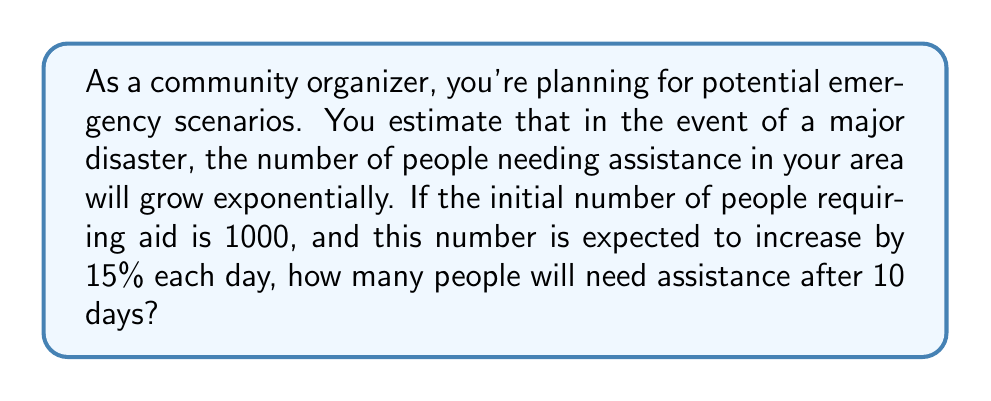Provide a solution to this math problem. Let's approach this step-by-step using an exponential function:

1) The general form of an exponential growth function is:
   $$ P(t) = P_0 \cdot (1 + r)^t $$
   Where:
   $P(t)$ is the population at time $t$
   $P_0$ is the initial population
   $r$ is the growth rate (as a decimal)
   $t$ is the time period

2) In this problem:
   $P_0 = 1000$ (initial population)
   $r = 0.15$ (15% growth rate expressed as a decimal)
   $t = 10$ days

3) Plugging these values into our formula:
   $$ P(10) = 1000 \cdot (1 + 0.15)^{10} $$

4) Simplify inside the parentheses:
   $$ P(10) = 1000 \cdot (1.15)^{10} $$

5) Calculate $(1.15)^{10}$:
   $$ (1.15)^{10} \approx 4.0456 $$

6) Multiply by the initial population:
   $$ P(10) = 1000 \cdot 4.0456 = 4045.6 $$

7) Since we're dealing with people, we round up to the nearest whole number:
   $$ P(10) = 4046 $$
Answer: 4046 people 